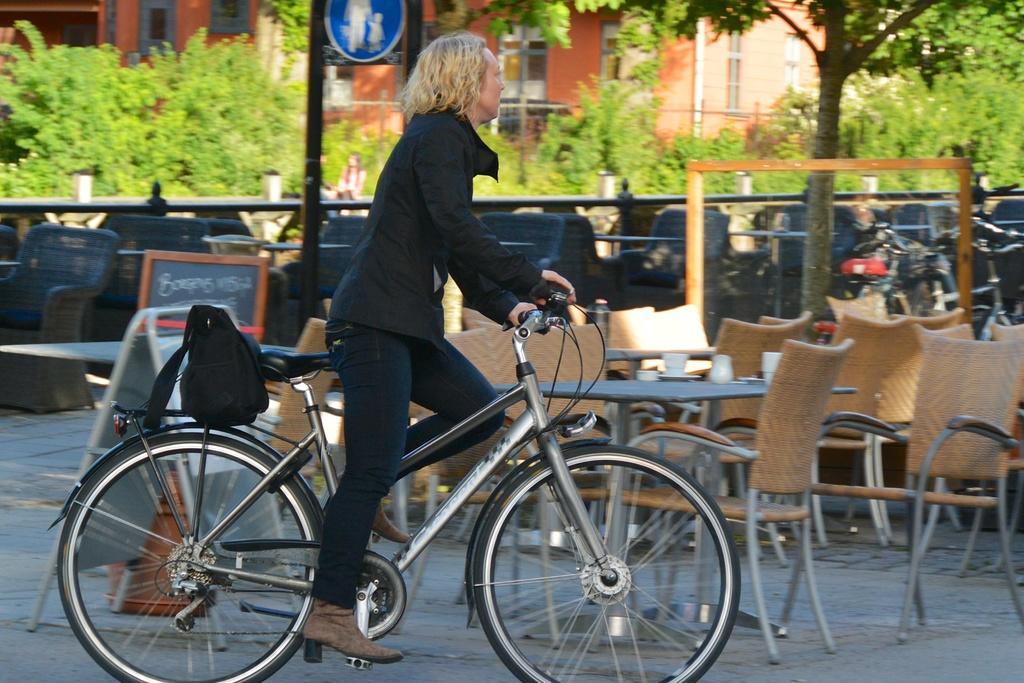In one or two sentences, can you explain what this image depicts? This picture is clicked outside the room. Here, we see woman in black jacket is riding bicycle. She is carrying her black bag along with her and beside her, we see many tables and chair placed on the floor. Beside that, we even will find some benches and behind that, we see trees and red color building. Behind the women, we see board and pole. 